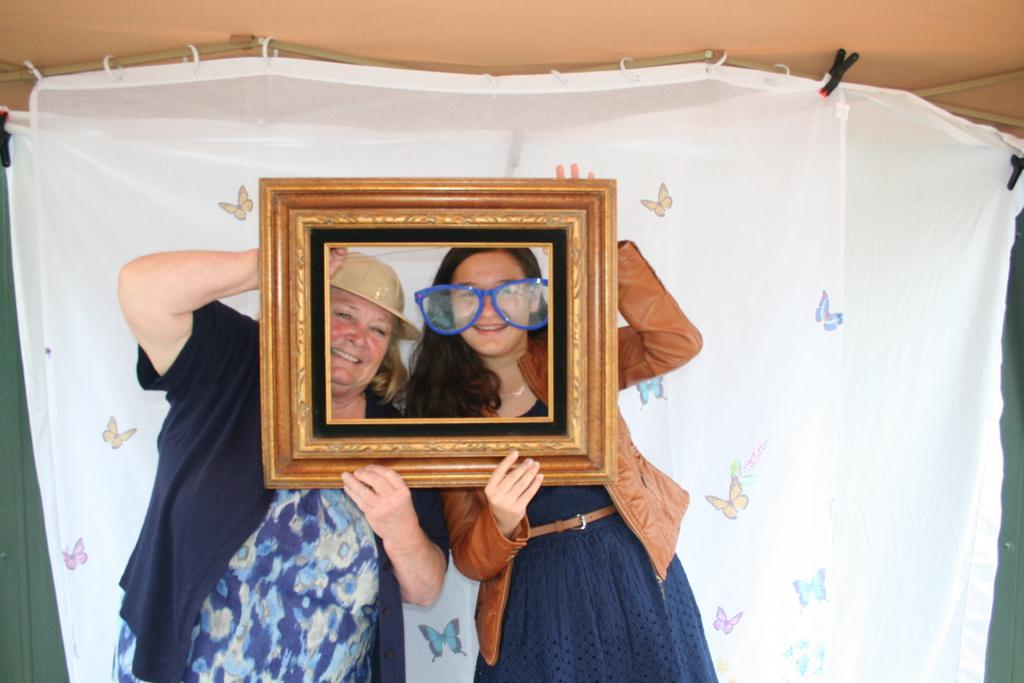How many people are in the image? There are two women in the image. What are the women doing in the image? The women are standing and holding a frame. Can you describe any additional details about the image? There is a curtain clipped with a pin on the backside, and a roof is visible in the image. What type of fuel is the grandfather using in the image? There is no grandfather or fuel present in the image. How does the police officer interact with the women in the image? There is no police officer present in the image. 